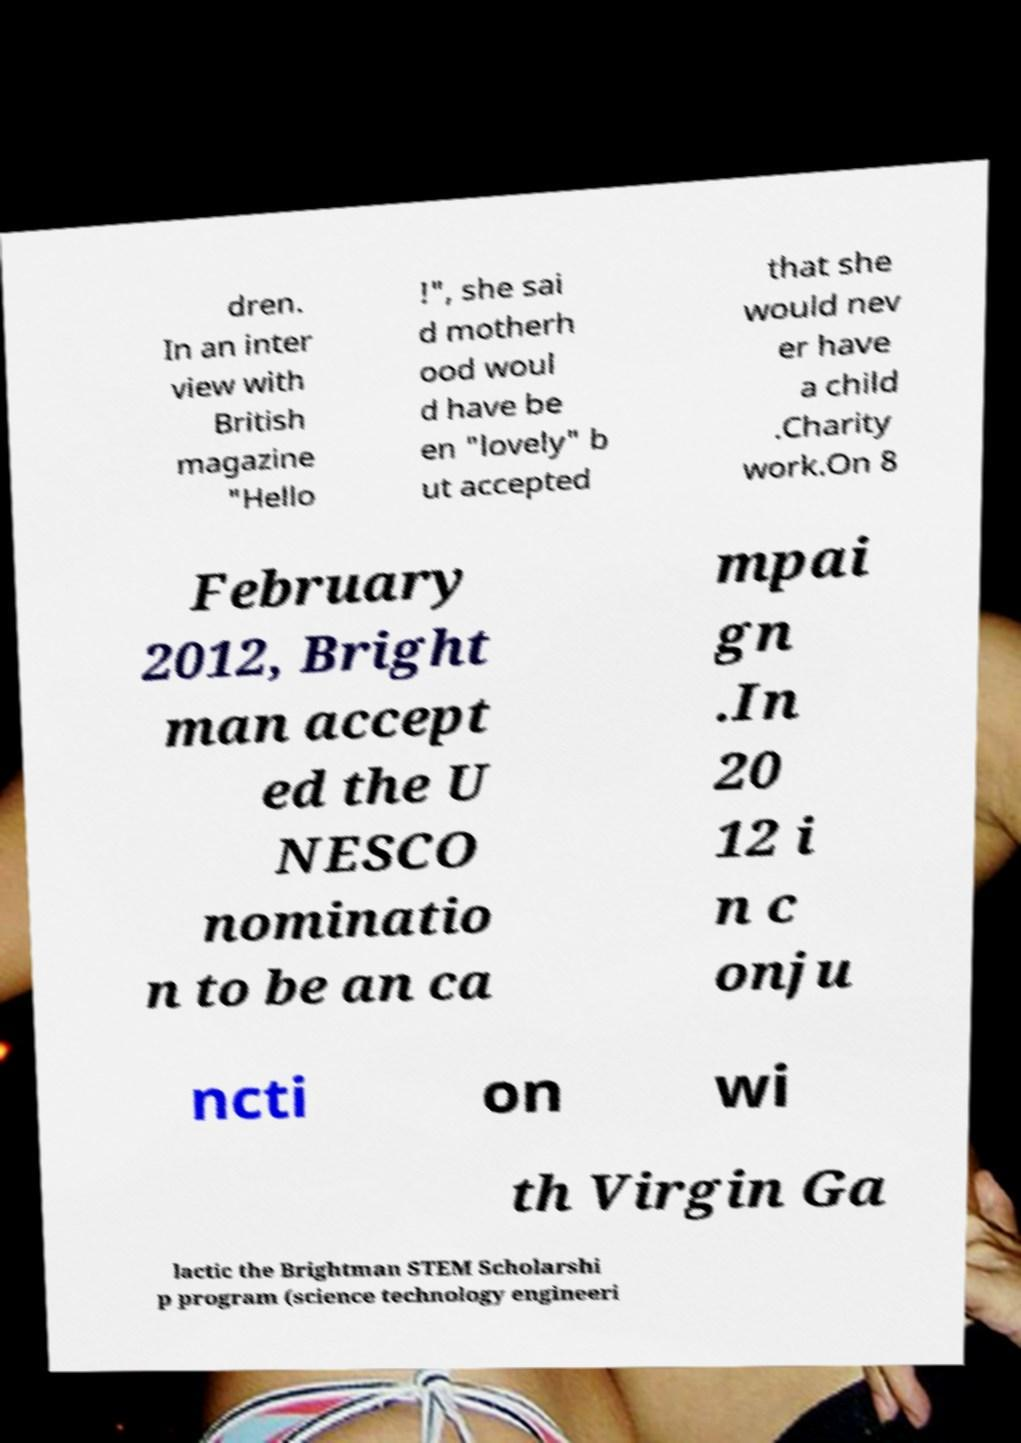Could you assist in decoding the text presented in this image and type it out clearly? dren. In an inter view with British magazine "Hello !", she sai d motherh ood woul d have be en "lovely" b ut accepted that she would nev er have a child .Charity work.On 8 February 2012, Bright man accept ed the U NESCO nominatio n to be an ca mpai gn .In 20 12 i n c onju ncti on wi th Virgin Ga lactic the Brightman STEM Scholarshi p program (science technology engineeri 